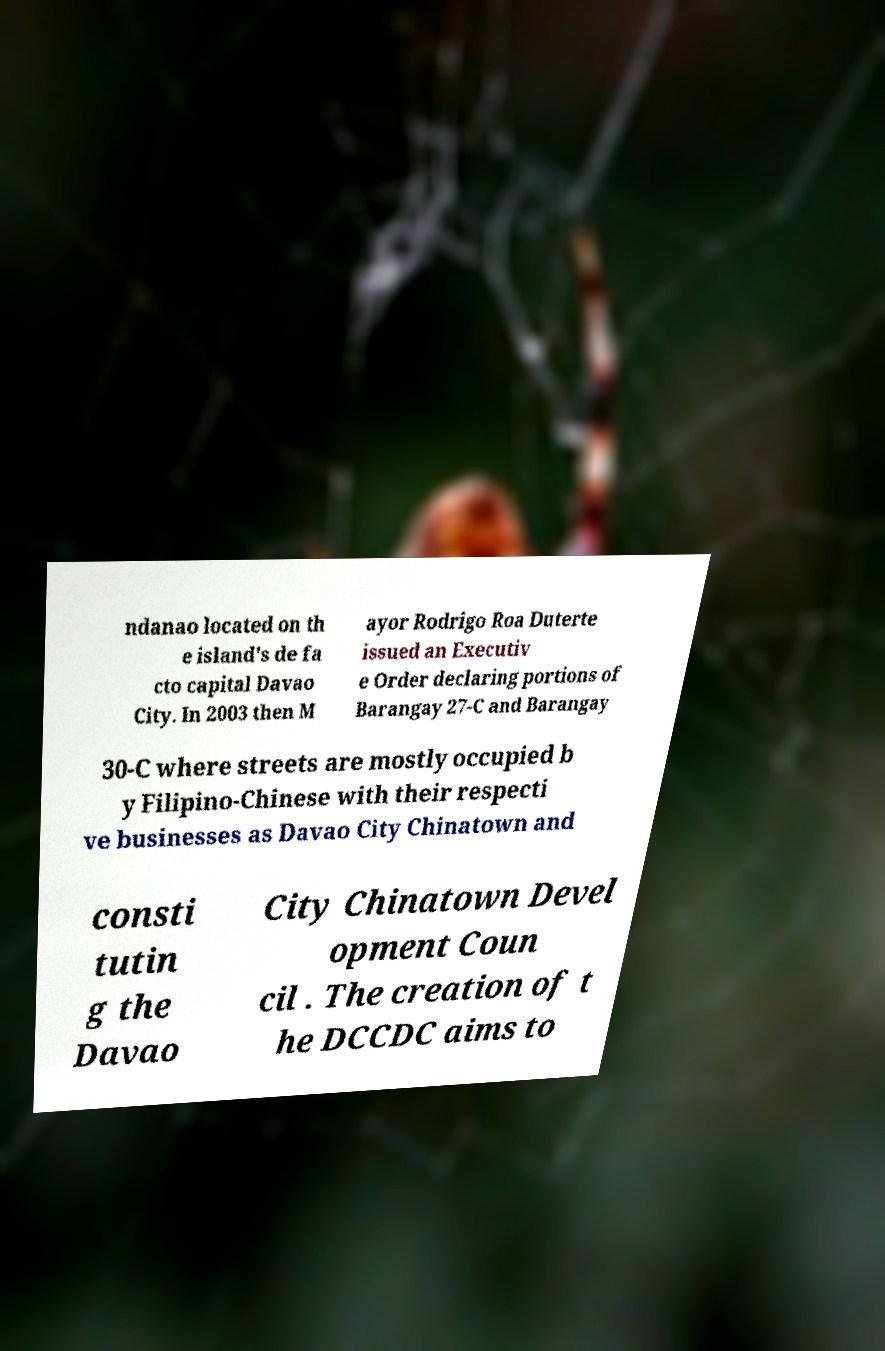There's text embedded in this image that I need extracted. Can you transcribe it verbatim? ndanao located on th e island's de fa cto capital Davao City. In 2003 then M ayor Rodrigo Roa Duterte issued an Executiv e Order declaring portions of Barangay 27-C and Barangay 30-C where streets are mostly occupied b y Filipino-Chinese with their respecti ve businesses as Davao City Chinatown and consti tutin g the Davao City Chinatown Devel opment Coun cil . The creation of t he DCCDC aims to 